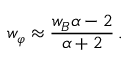<formula> <loc_0><loc_0><loc_500><loc_500>w _ { \varphi } \approx \frac { w _ { B } \alpha - 2 } { \alpha + 2 } \, .</formula> 